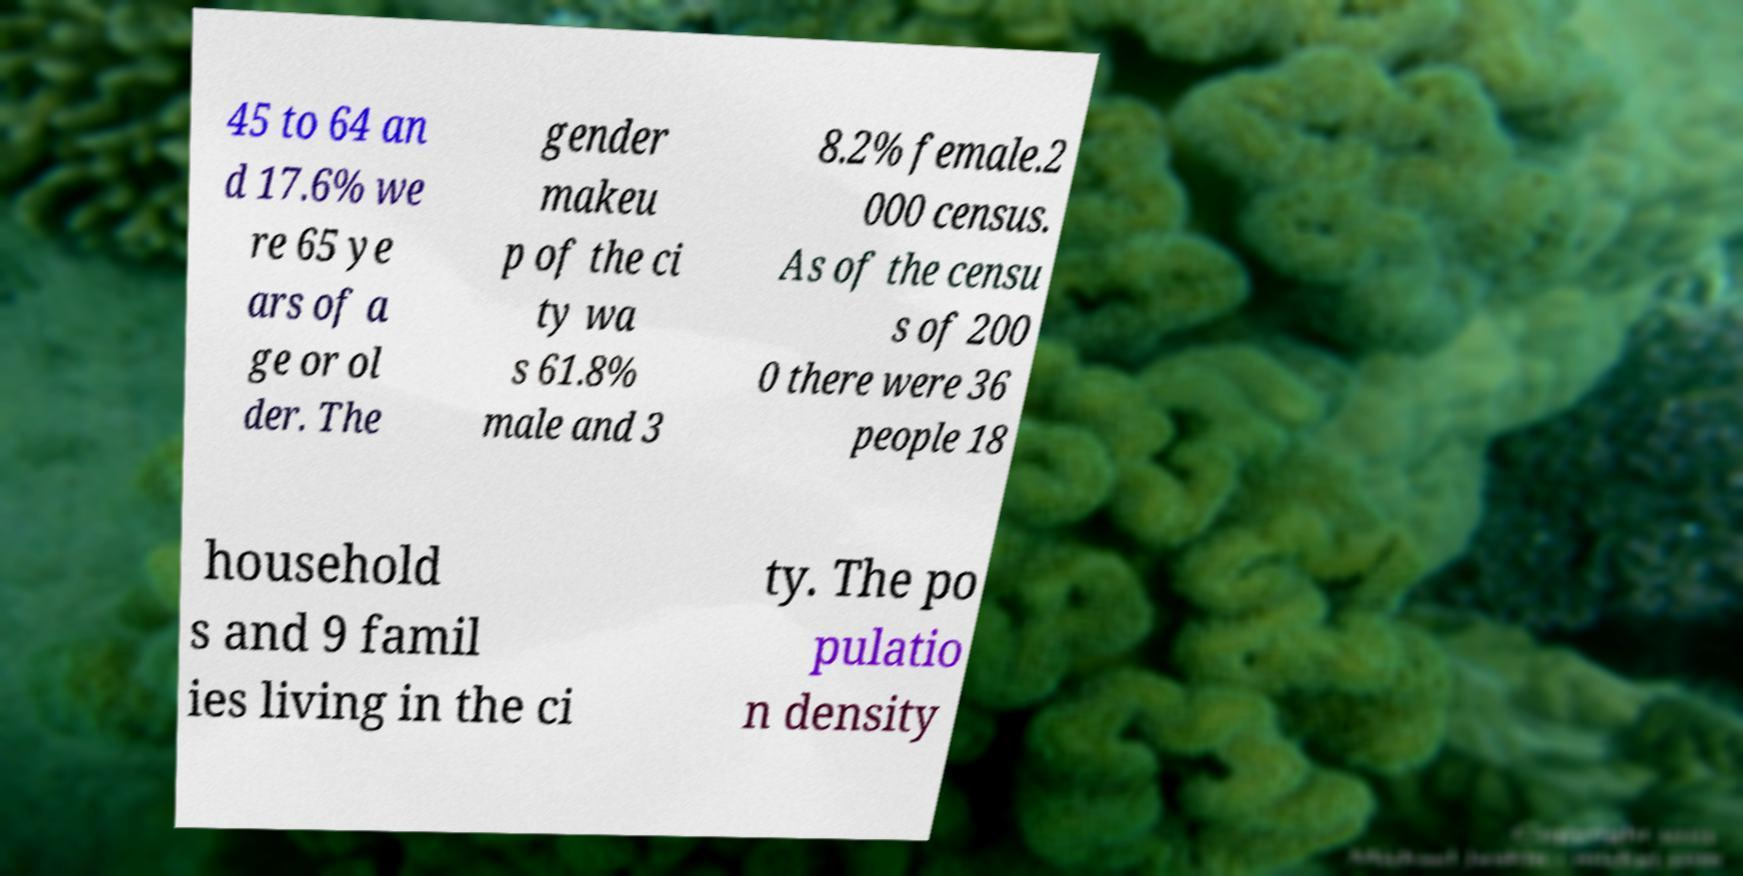Please identify and transcribe the text found in this image. 45 to 64 an d 17.6% we re 65 ye ars of a ge or ol der. The gender makeu p of the ci ty wa s 61.8% male and 3 8.2% female.2 000 census. As of the censu s of 200 0 there were 36 people 18 household s and 9 famil ies living in the ci ty. The po pulatio n density 